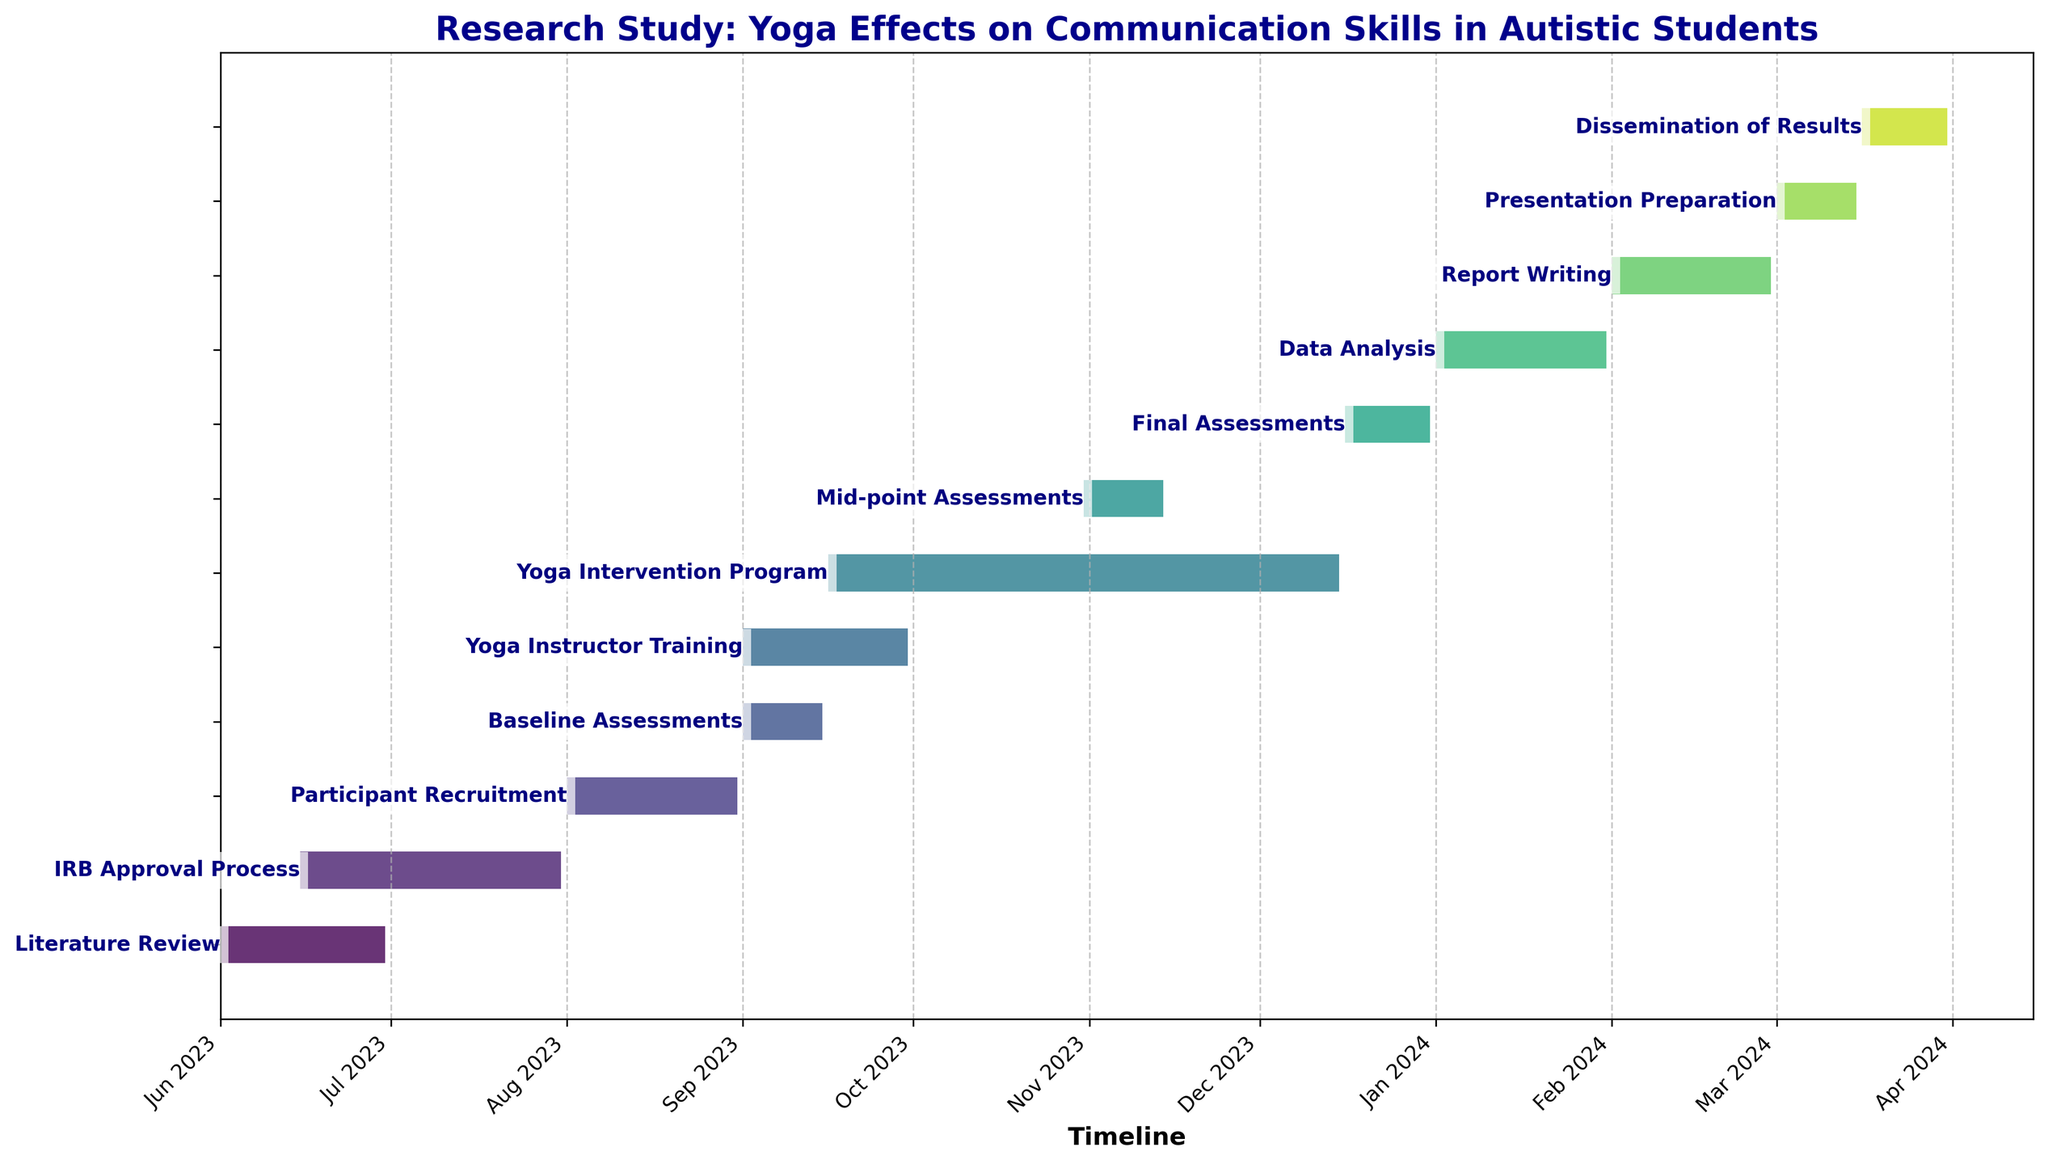What is the title of the Gantt Chart? The title is found at the top of the Gantt Chart and provides a summary of the figure's purpose.
Answer: Research Study: Yoga Effects on Communication Skills in Autistic Students How long is the Yoga Instructor Training task? Look at the duration for Yoga Instructor Training in the chart's task list, which shows the duration in days.
Answer: 30 days When does the Mid-point Assessments task start and end? The start and end dates for each task are indicated along the horizontal axis of the Gantt Chart. Locate the Mid-point Assessments task bar and read the dates.
Answer: Starts on 2023-10-31 and ends on 2023-11-14 How many tasks are conducted simultaneously starting from 2023-09-01? Identify the tasks that overlap starting on 2023-09-01 by checking the bars that begin or are ongoing from that date.
Answer: 3 tasks (Baseline Assessments, Yoga Instructor Training, Yoga Intervention Program) Which task has the longest duration, and how many days does it last? Analyze the length of each bar in the Gantt Chart, compare their duration by their left-to-right span.
Answer: Yoga Intervention Program, 91 days Compare the start date of Participant Recruitment and Baseline Assessments. Which one begins first and by how many days? Examine the start dates for both tasks and calculate the difference between their begin dates.
Answer: Participant Recruitment begins first by 31 days (Participant Recruitment starts on 2023-08-01, Baseline Assessments starts on 2023-09-01) How do the durations of Report Writing and Data Analysis compare? Check the duration in days for both tasks listed in the chart and compare the numbers.
Answer: Data Analysis duration (31 days) is longer than Report Writing (29 days) by 2 days Which task concludes the entire research study, and when does it end? Look at the task that is positioned last on the timeline and check its end date.
Answer: Dissemination of Results, ends on 2024-03-31 If the IRB Approval Process is delayed by 15 days, will it affect the start of the Participant Recruitment task? Evaluate the end date of the possibly delayed IRB Approval Process and compare it with the start date of Participant Recruitment.
Answer: No, the IRB Approval Process (ends on 2023-07-31) and Participant Recruitment (starts on 2023-08-01) have no direct overlap after adjustment What is the total duration from the beginning of the Literature Review to the end of the Dissemination of Results? Calculate the time span from the Literature Review start date to the Dissemination of Results end date.
Answer: From 2023-06-01 to 2024-03-31 is 305 days 